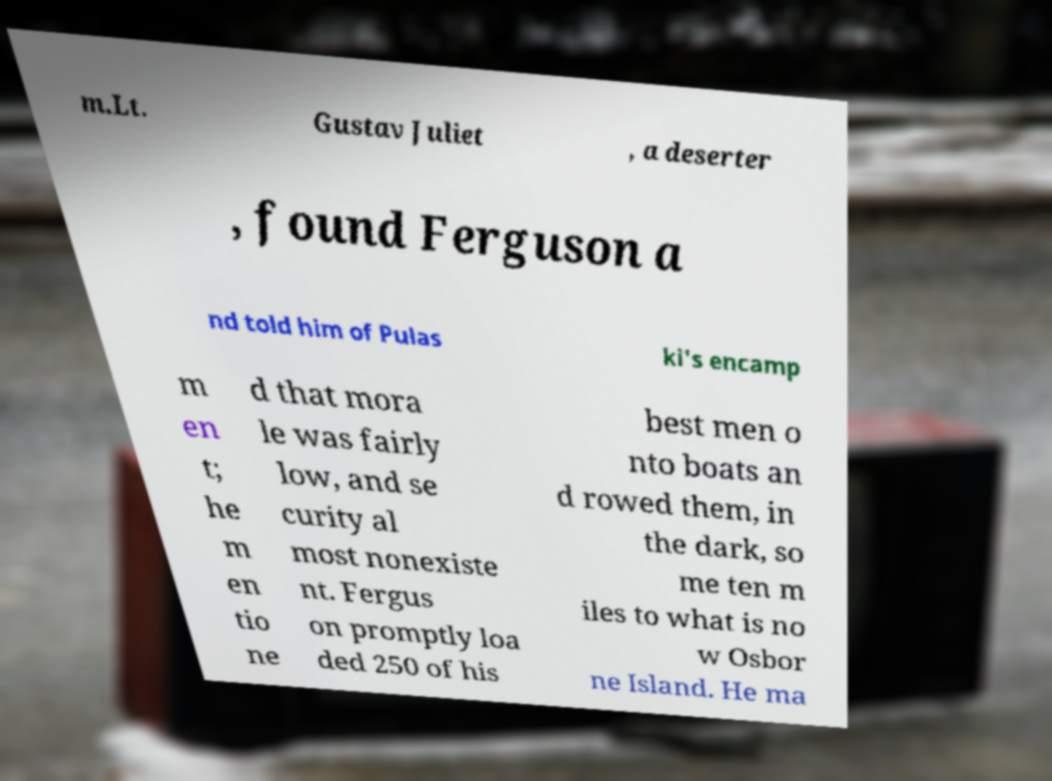Please read and relay the text visible in this image. What does it say? m.Lt. Gustav Juliet , a deserter , found Ferguson a nd told him of Pulas ki's encamp m en t; he m en tio ne d that mora le was fairly low, and se curity al most nonexiste nt. Fergus on promptly loa ded 250 of his best men o nto boats an d rowed them, in the dark, so me ten m iles to what is no w Osbor ne Island. He ma 